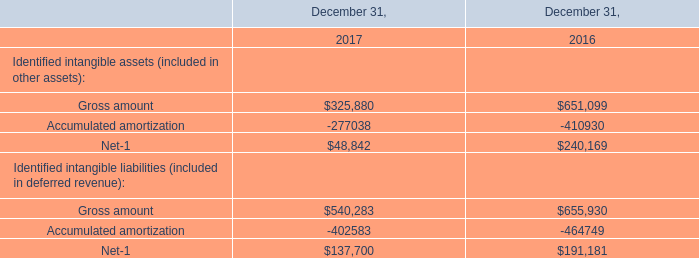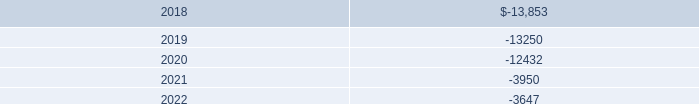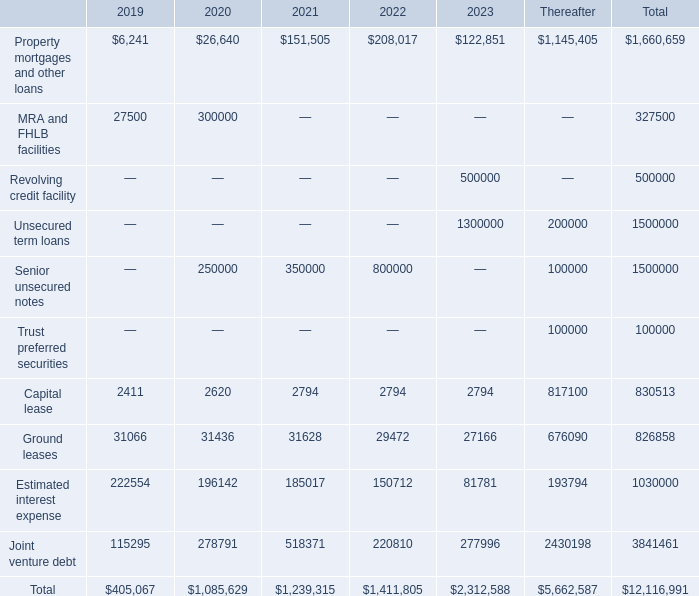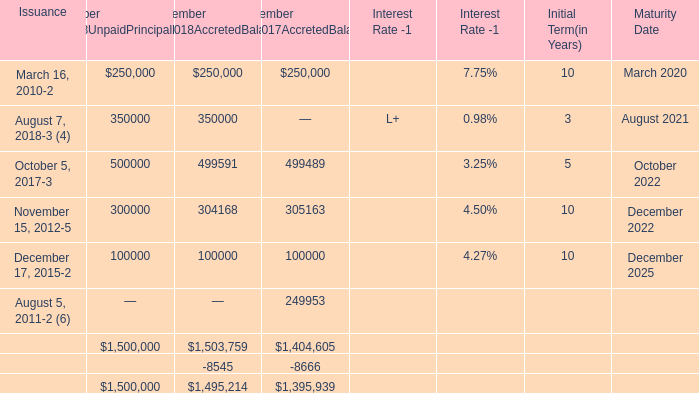What is the average amount of Gross amount of December 31, 2016, and March 16, 2010 of December 31,2018AccretedBalance ? 
Computations: ((651099.0 + 250000.0) / 2)
Answer: 450549.5. 